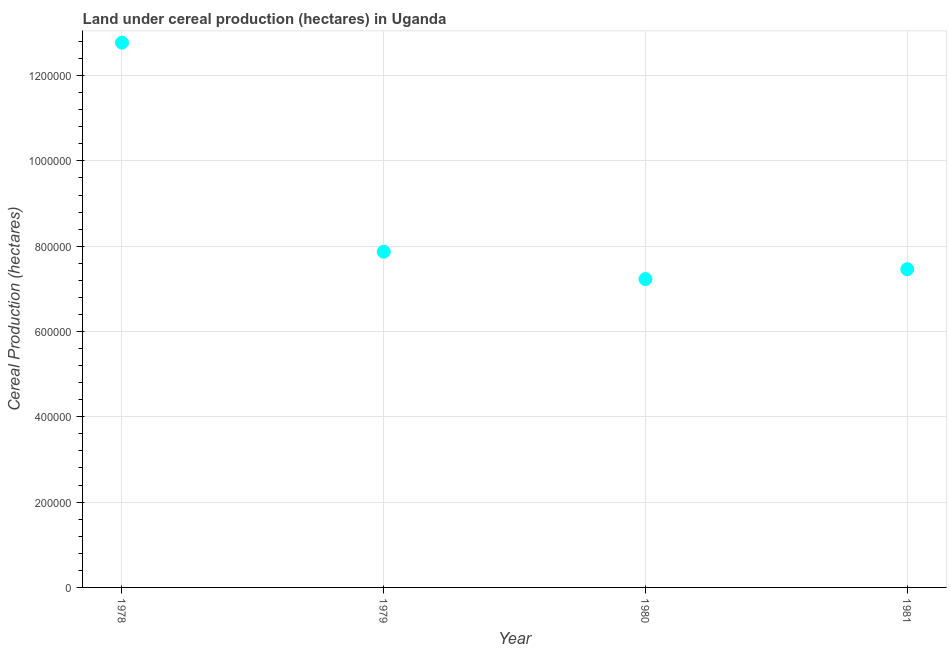What is the land under cereal production in 1980?
Provide a short and direct response. 7.23e+05. Across all years, what is the maximum land under cereal production?
Give a very brief answer. 1.28e+06. Across all years, what is the minimum land under cereal production?
Ensure brevity in your answer.  7.23e+05. In which year was the land under cereal production maximum?
Your response must be concise. 1978. In which year was the land under cereal production minimum?
Give a very brief answer. 1980. What is the sum of the land under cereal production?
Your answer should be compact. 3.53e+06. What is the difference between the land under cereal production in 1978 and 1979?
Give a very brief answer. 4.90e+05. What is the average land under cereal production per year?
Ensure brevity in your answer.  8.83e+05. What is the median land under cereal production?
Your answer should be compact. 7.66e+05. In how many years, is the land under cereal production greater than 200000 hectares?
Keep it short and to the point. 4. Do a majority of the years between 1980 and 1979 (inclusive) have land under cereal production greater than 520000 hectares?
Your response must be concise. No. What is the ratio of the land under cereal production in 1980 to that in 1981?
Offer a very short reply. 0.97. Is the difference between the land under cereal production in 1978 and 1981 greater than the difference between any two years?
Offer a terse response. No. What is the difference between the highest and the second highest land under cereal production?
Offer a very short reply. 4.90e+05. What is the difference between the highest and the lowest land under cereal production?
Your response must be concise. 5.54e+05. Does the land under cereal production monotonically increase over the years?
Make the answer very short. No. Does the graph contain any zero values?
Your answer should be compact. No. What is the title of the graph?
Ensure brevity in your answer.  Land under cereal production (hectares) in Uganda. What is the label or title of the X-axis?
Your answer should be compact. Year. What is the label or title of the Y-axis?
Ensure brevity in your answer.  Cereal Production (hectares). What is the Cereal Production (hectares) in 1978?
Provide a short and direct response. 1.28e+06. What is the Cereal Production (hectares) in 1979?
Provide a succinct answer. 7.87e+05. What is the Cereal Production (hectares) in 1980?
Offer a very short reply. 7.23e+05. What is the Cereal Production (hectares) in 1981?
Offer a very short reply. 7.46e+05. What is the difference between the Cereal Production (hectares) in 1978 and 1979?
Offer a very short reply. 4.90e+05. What is the difference between the Cereal Production (hectares) in 1978 and 1980?
Your response must be concise. 5.54e+05. What is the difference between the Cereal Production (hectares) in 1978 and 1981?
Offer a terse response. 5.31e+05. What is the difference between the Cereal Production (hectares) in 1979 and 1980?
Keep it short and to the point. 6.40e+04. What is the difference between the Cereal Production (hectares) in 1979 and 1981?
Offer a terse response. 4.10e+04. What is the difference between the Cereal Production (hectares) in 1980 and 1981?
Make the answer very short. -2.30e+04. What is the ratio of the Cereal Production (hectares) in 1978 to that in 1979?
Your response must be concise. 1.62. What is the ratio of the Cereal Production (hectares) in 1978 to that in 1980?
Provide a succinct answer. 1.77. What is the ratio of the Cereal Production (hectares) in 1978 to that in 1981?
Make the answer very short. 1.71. What is the ratio of the Cereal Production (hectares) in 1979 to that in 1980?
Your response must be concise. 1.09. What is the ratio of the Cereal Production (hectares) in 1979 to that in 1981?
Your answer should be compact. 1.05. 